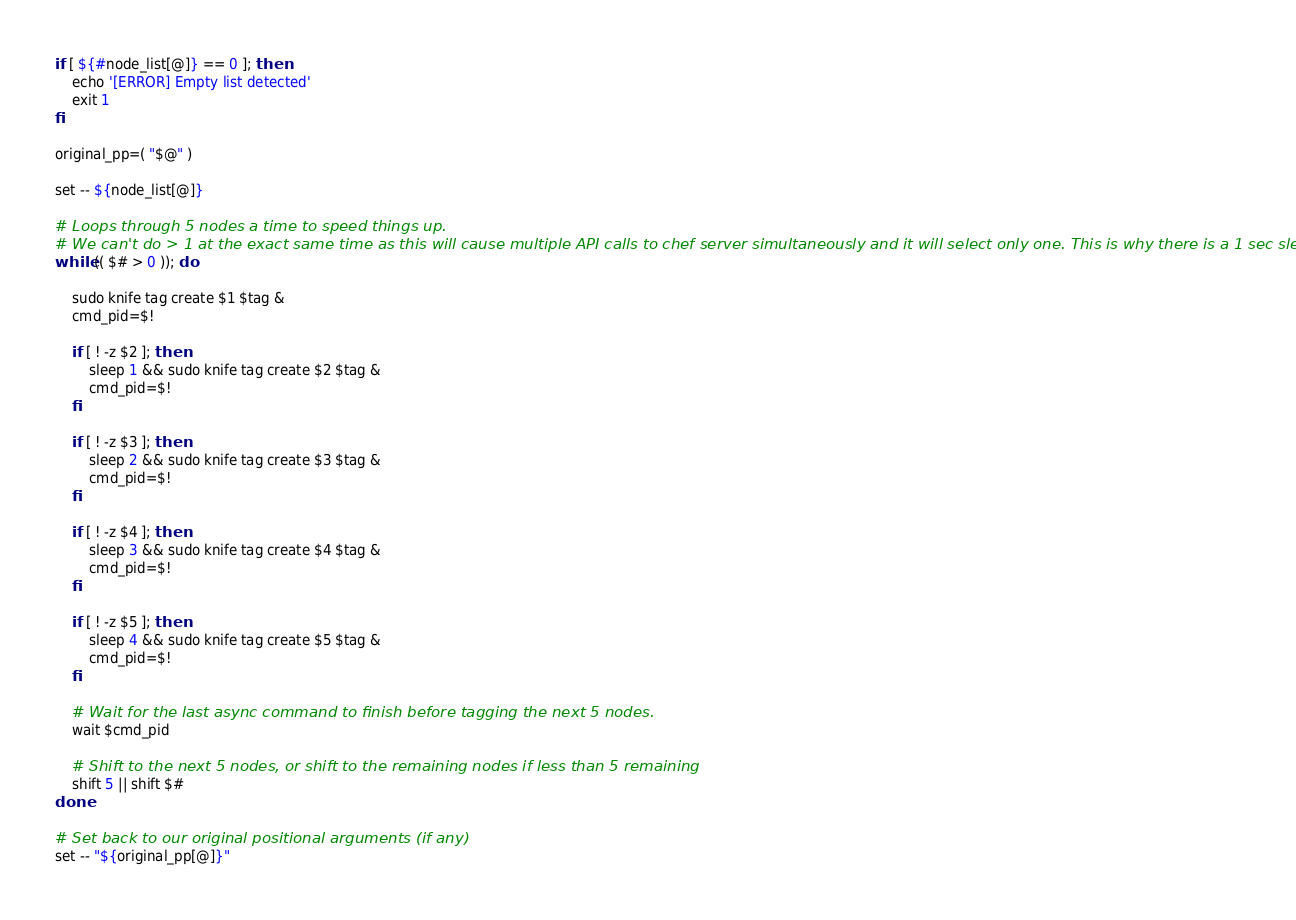Convert code to text. <code><loc_0><loc_0><loc_500><loc_500><_Bash_>if [ ${#node_list[@]} == 0 ]; then
    echo '[ERROR] Empty list detected'
    exit 1
fi

original_pp=( "$@" )

set -- ${node_list[@]}

# Loops through 5 nodes a time to speed things up.
# We can't do > 1 at the exact same time as this will cause multiple API calls to chef server simultaneously and it will select only one. This is why there is a 1 sec sleep added.
while (( $# > 0 )); do

    sudo knife tag create $1 $tag &
    cmd_pid=$!

    if [ ! -z $2 ]; then
        sleep 1 && sudo knife tag create $2 $tag &
        cmd_pid=$!
    fi

    if [ ! -z $3 ]; then
        sleep 2 && sudo knife tag create $3 $tag &
        cmd_pid=$!
    fi

    if [ ! -z $4 ]; then
        sleep 3 && sudo knife tag create $4 $tag &
        cmd_pid=$!
    fi

    if [ ! -z $5 ]; then
        sleep 4 && sudo knife tag create $5 $tag &
        cmd_pid=$!
    fi

    # Wait for the last async command to finish before tagging the next 5 nodes.
    wait $cmd_pid

    # Shift to the next 5 nodes, or shift to the remaining nodes if less than 5 remaining
    shift 5 || shift $#
done

# Set back to our original positional arguments (if any)
set -- "${original_pp[@]}"
</code> 